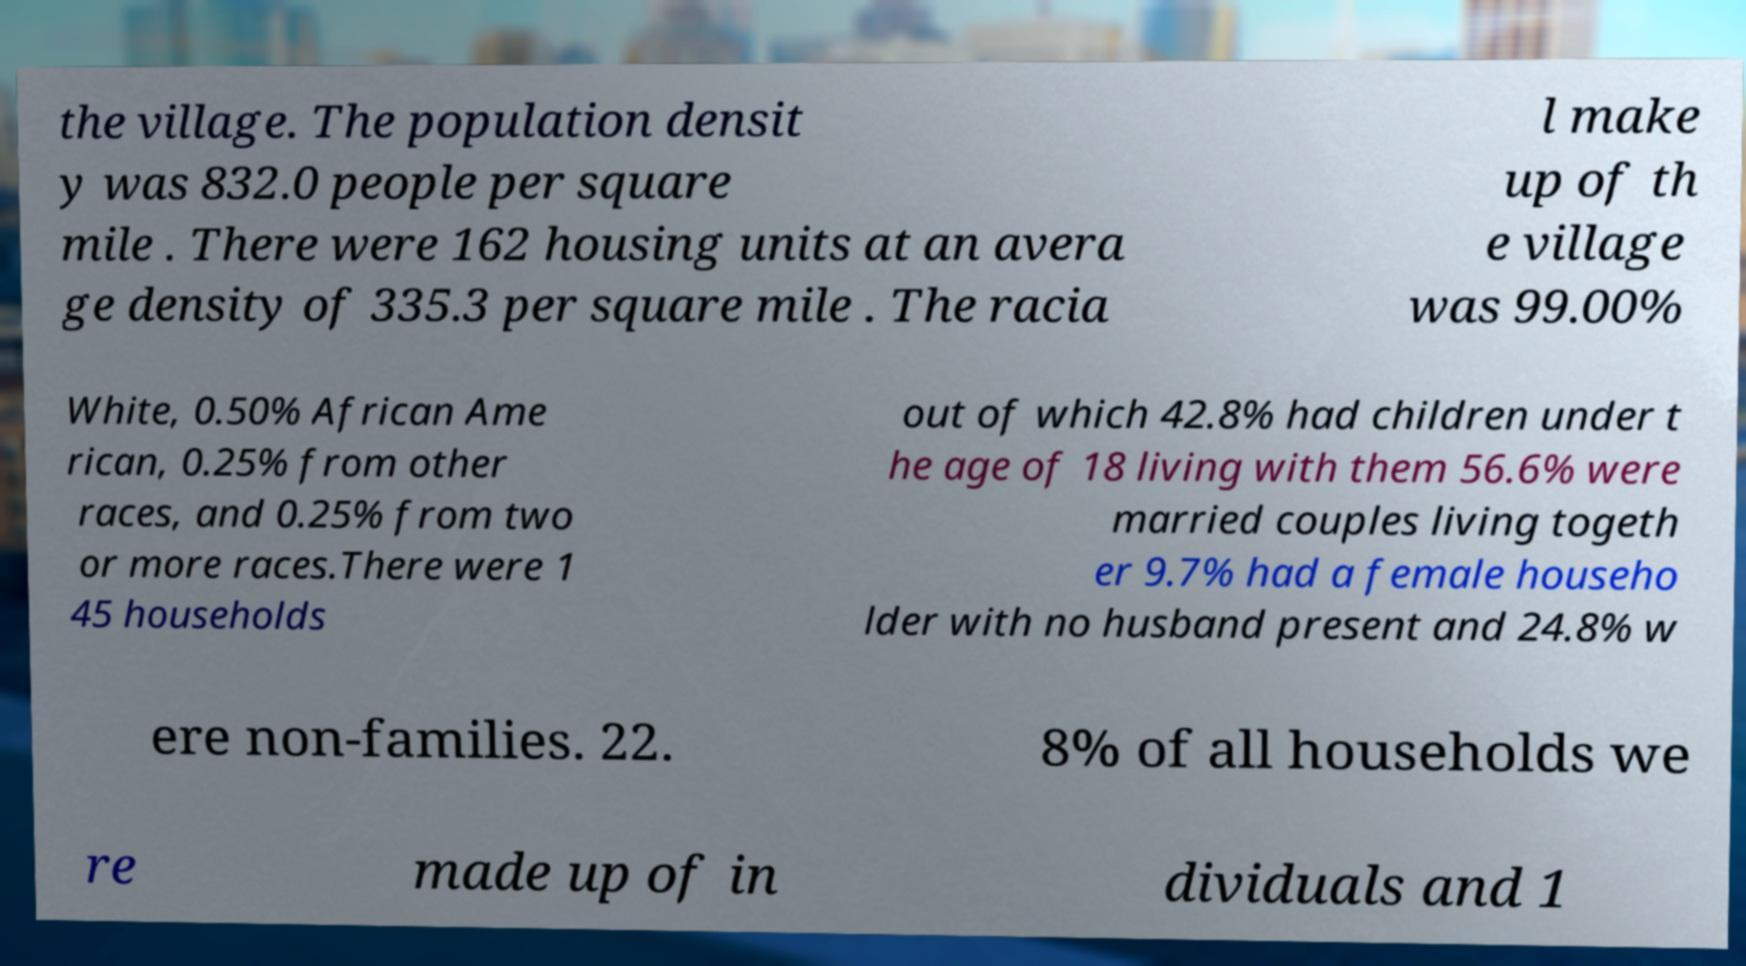There's text embedded in this image that I need extracted. Can you transcribe it verbatim? the village. The population densit y was 832.0 people per square mile . There were 162 housing units at an avera ge density of 335.3 per square mile . The racia l make up of th e village was 99.00% White, 0.50% African Ame rican, 0.25% from other races, and 0.25% from two or more races.There were 1 45 households out of which 42.8% had children under t he age of 18 living with them 56.6% were married couples living togeth er 9.7% had a female househo lder with no husband present and 24.8% w ere non-families. 22. 8% of all households we re made up of in dividuals and 1 